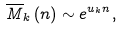<formula> <loc_0><loc_0><loc_500><loc_500>\overline { M } _ { k } \left ( n \right ) \sim e ^ { u _ { k } n } ,</formula> 